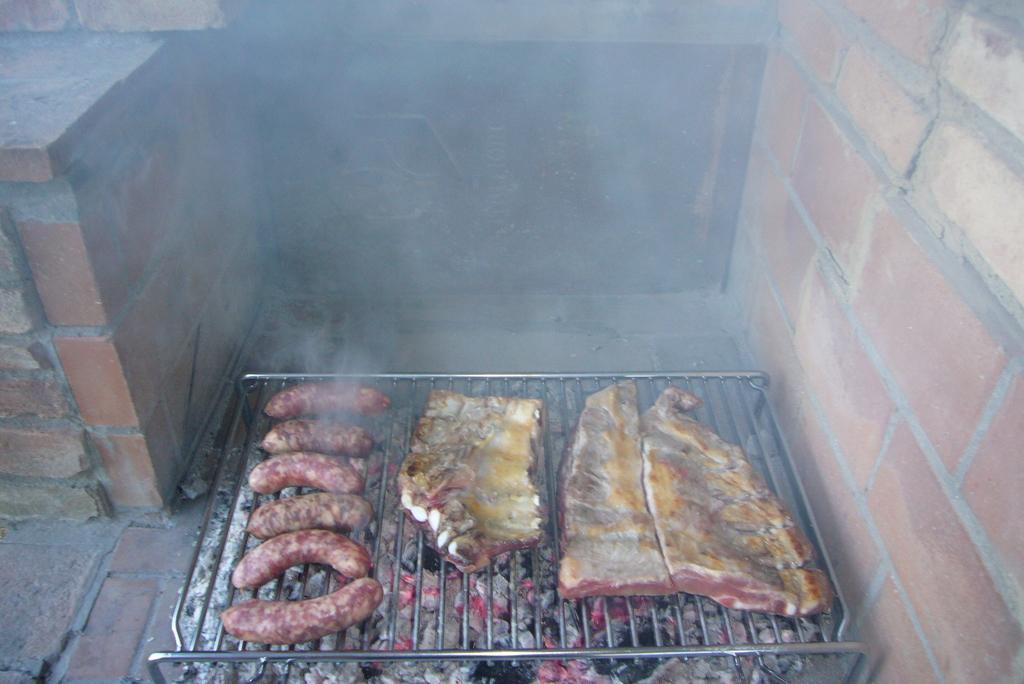Describe this image in one or two sentences. In this image we can see a grill and there is a meat placed on the grill. In the background we can see a brick wall. 